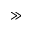<formula> <loc_0><loc_0><loc_500><loc_500>{ \gg }</formula> 